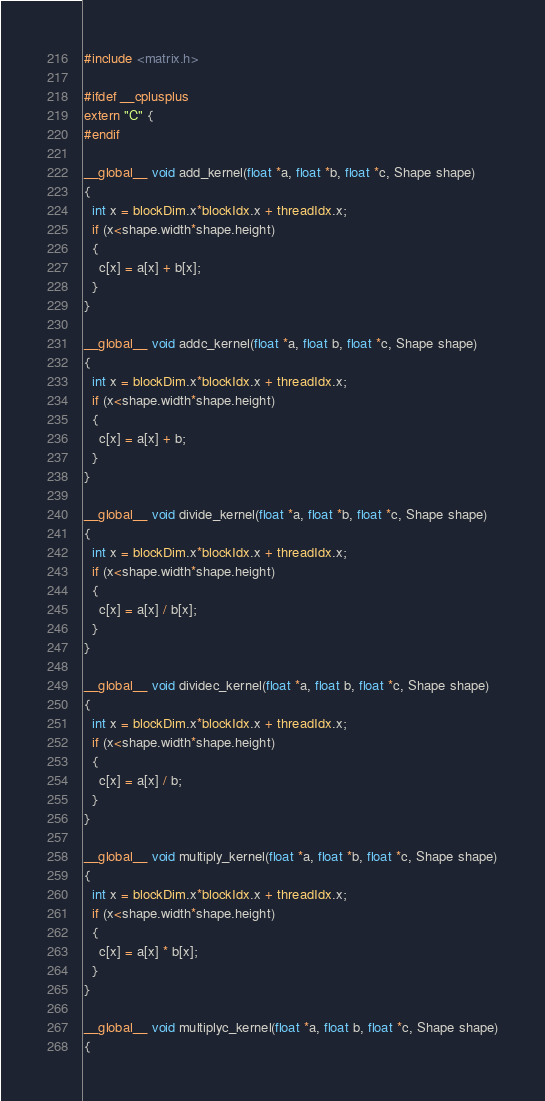Convert code to text. <code><loc_0><loc_0><loc_500><loc_500><_Cuda_>#include <matrix.h>

#ifdef __cplusplus
extern "C" {
#endif

__global__ void add_kernel(float *a, float *b, float *c, Shape shape)
{
  int x = blockDim.x*blockIdx.x + threadIdx.x;
  if (x<shape.width*shape.height)
  {
    c[x] = a[x] + b[x];
  }
}

__global__ void addc_kernel(float *a, float b, float *c, Shape shape)
{
  int x = blockDim.x*blockIdx.x + threadIdx.x;
  if (x<shape.width*shape.height)
  {
    c[x] = a[x] + b;
  }
}

__global__ void divide_kernel(float *a, float *b, float *c, Shape shape)
{
  int x = blockDim.x*blockIdx.x + threadIdx.x;
  if (x<shape.width*shape.height)
  {
    c[x] = a[x] / b[x];
  }
}

__global__ void dividec_kernel(float *a, float b, float *c, Shape shape)
{
  int x = blockDim.x*blockIdx.x + threadIdx.x;
  if (x<shape.width*shape.height)
  {
    c[x] = a[x] / b;
  }
}

__global__ void multiply_kernel(float *a, float *b, float *c, Shape shape)
{
  int x = blockDim.x*blockIdx.x + threadIdx.x;
  if (x<shape.width*shape.height)
  {
    c[x] = a[x] * b[x];
  }
}

__global__ void multiplyc_kernel(float *a, float b, float *c, Shape shape)
{</code> 